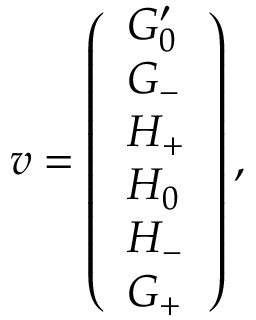Convert formula to latex. <formula><loc_0><loc_0><loc_500><loc_500>v = \left ( \begin{array} { l } { G _ { 0 } ^ { \prime } } \\ { G _ { - } } \\ { H _ { + } } \\ { H _ { 0 } } \\ { H _ { - } } \\ { G _ { + } } \end{array} \right ) ,</formula> 